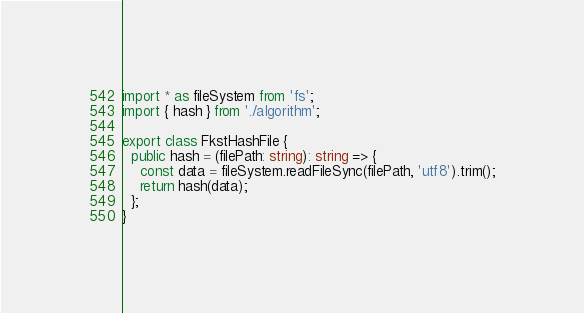<code> <loc_0><loc_0><loc_500><loc_500><_TypeScript_>import * as fileSystem from 'fs';
import { hash } from './algorithm';

export class FkstHashFile {
  public hash = (filePath: string): string => {
    const data = fileSystem.readFileSync(filePath, 'utf8').trim();
    return hash(data);
  };
}
</code> 